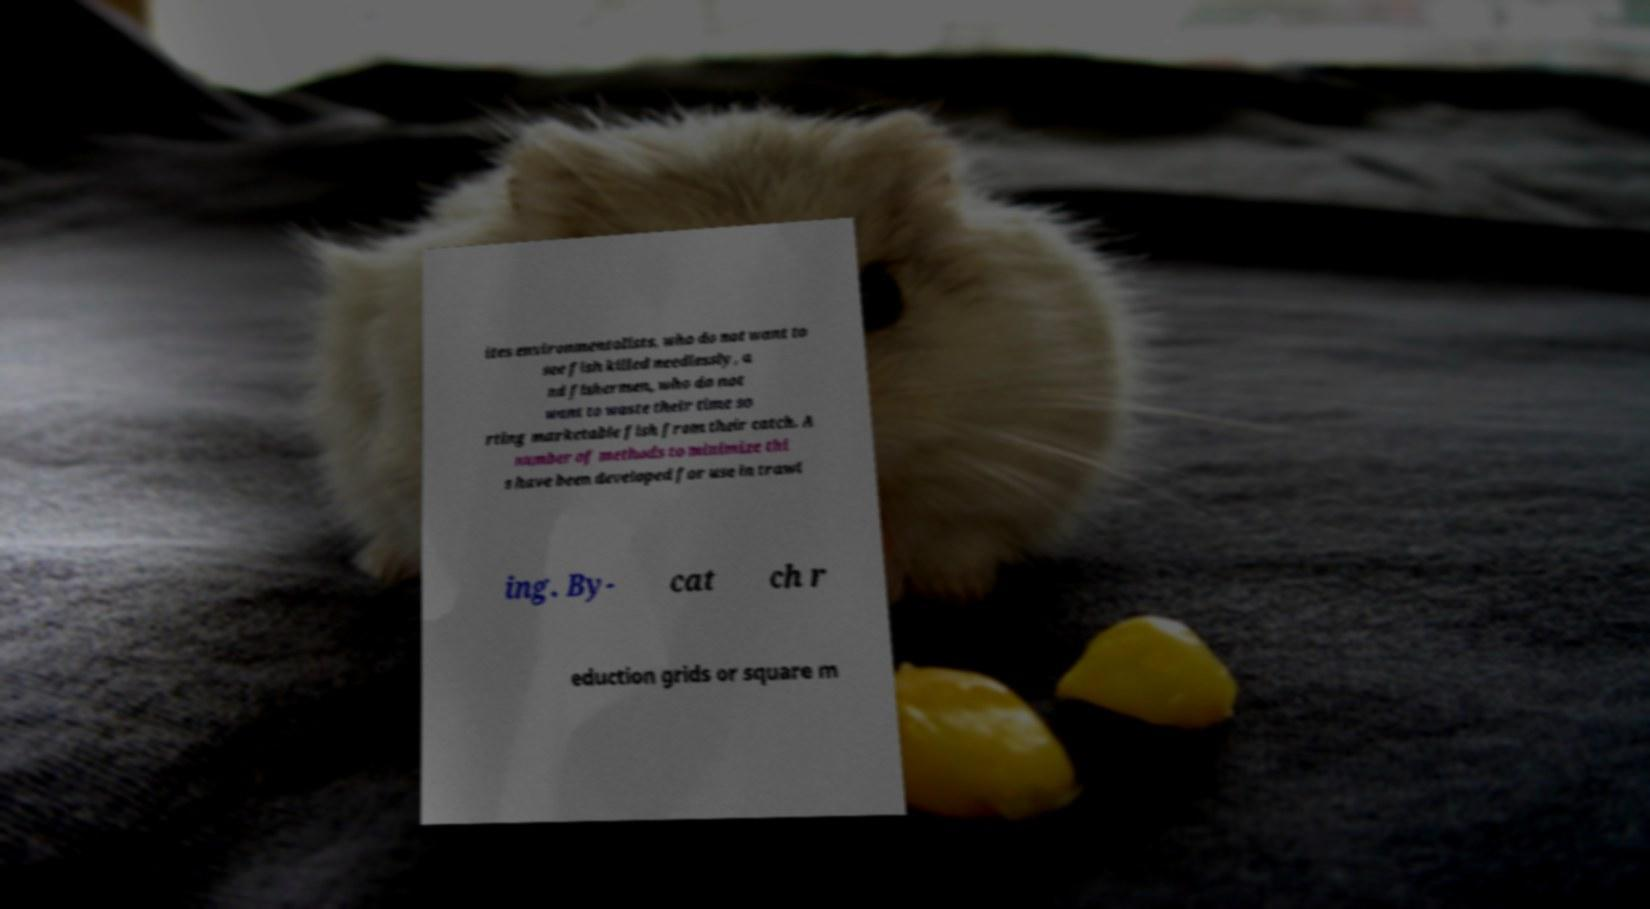Please read and relay the text visible in this image. What does it say? ites environmentalists, who do not want to see fish killed needlessly, a nd fishermen, who do not want to waste their time so rting marketable fish from their catch. A number of methods to minimize thi s have been developed for use in trawl ing. By- cat ch r eduction grids or square m 